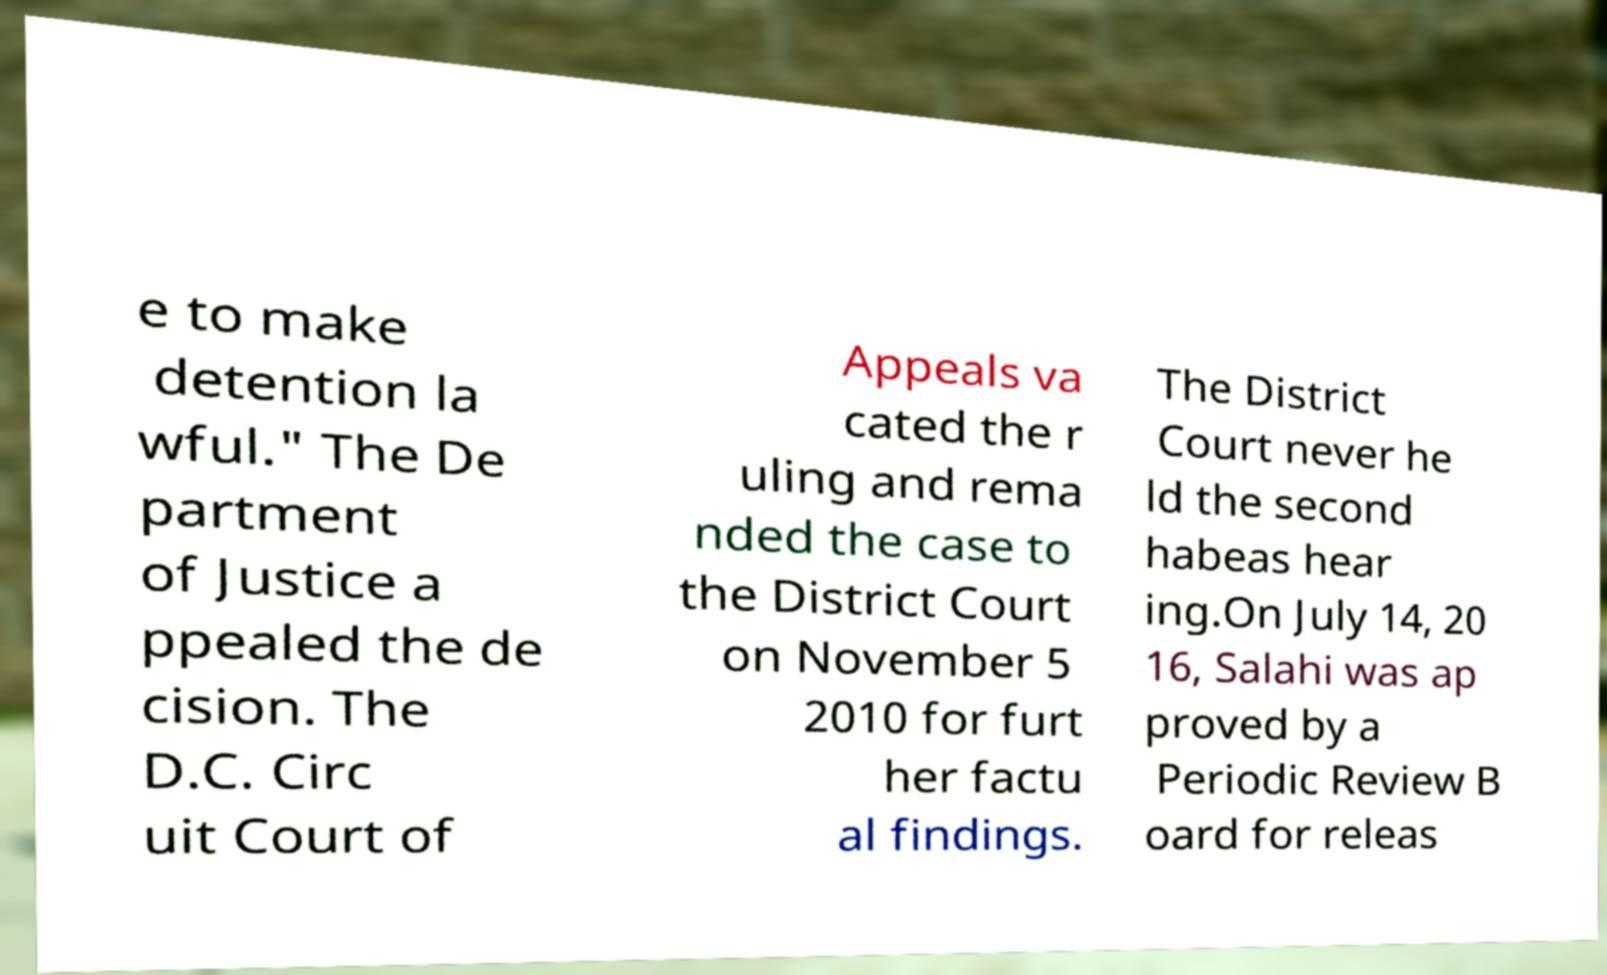Can you read and provide the text displayed in the image?This photo seems to have some interesting text. Can you extract and type it out for me? e to make detention la wful." The De partment of Justice a ppealed the de cision. The D.C. Circ uit Court of Appeals va cated the r uling and rema nded the case to the District Court on November 5 2010 for furt her factu al findings. The District Court never he ld the second habeas hear ing.On July 14, 20 16, Salahi was ap proved by a Periodic Review B oard for releas 